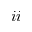Convert formula to latex. <formula><loc_0><loc_0><loc_500><loc_500>{ \romannumeral 2 }</formula> 